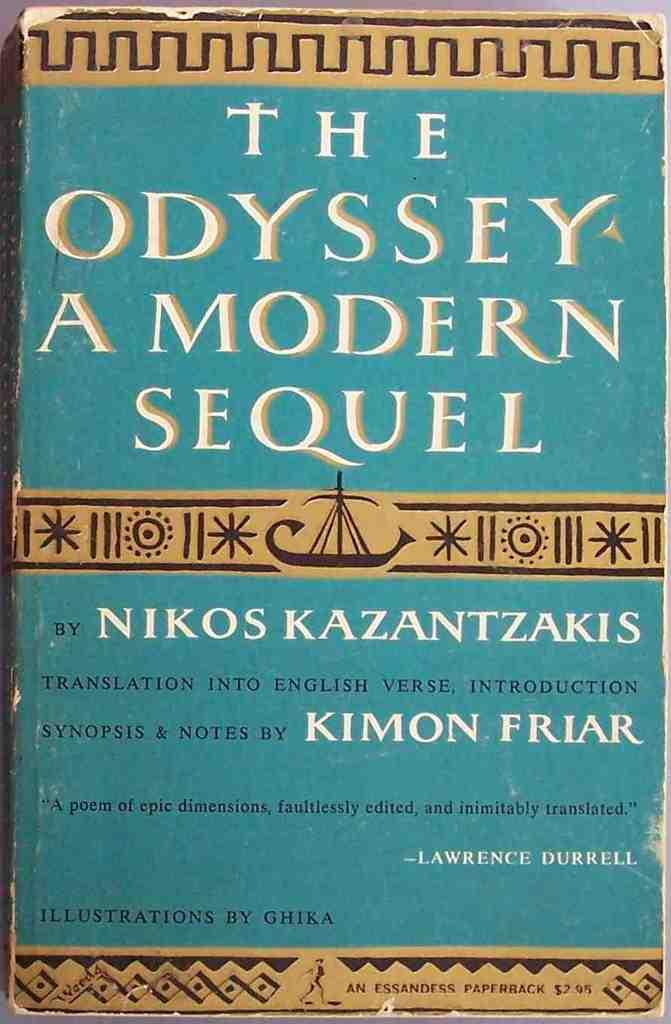<image>
Render a clear and concise summary of the photo. The Odyssey A Modern Sequel by Nikos Kazantzakis. 